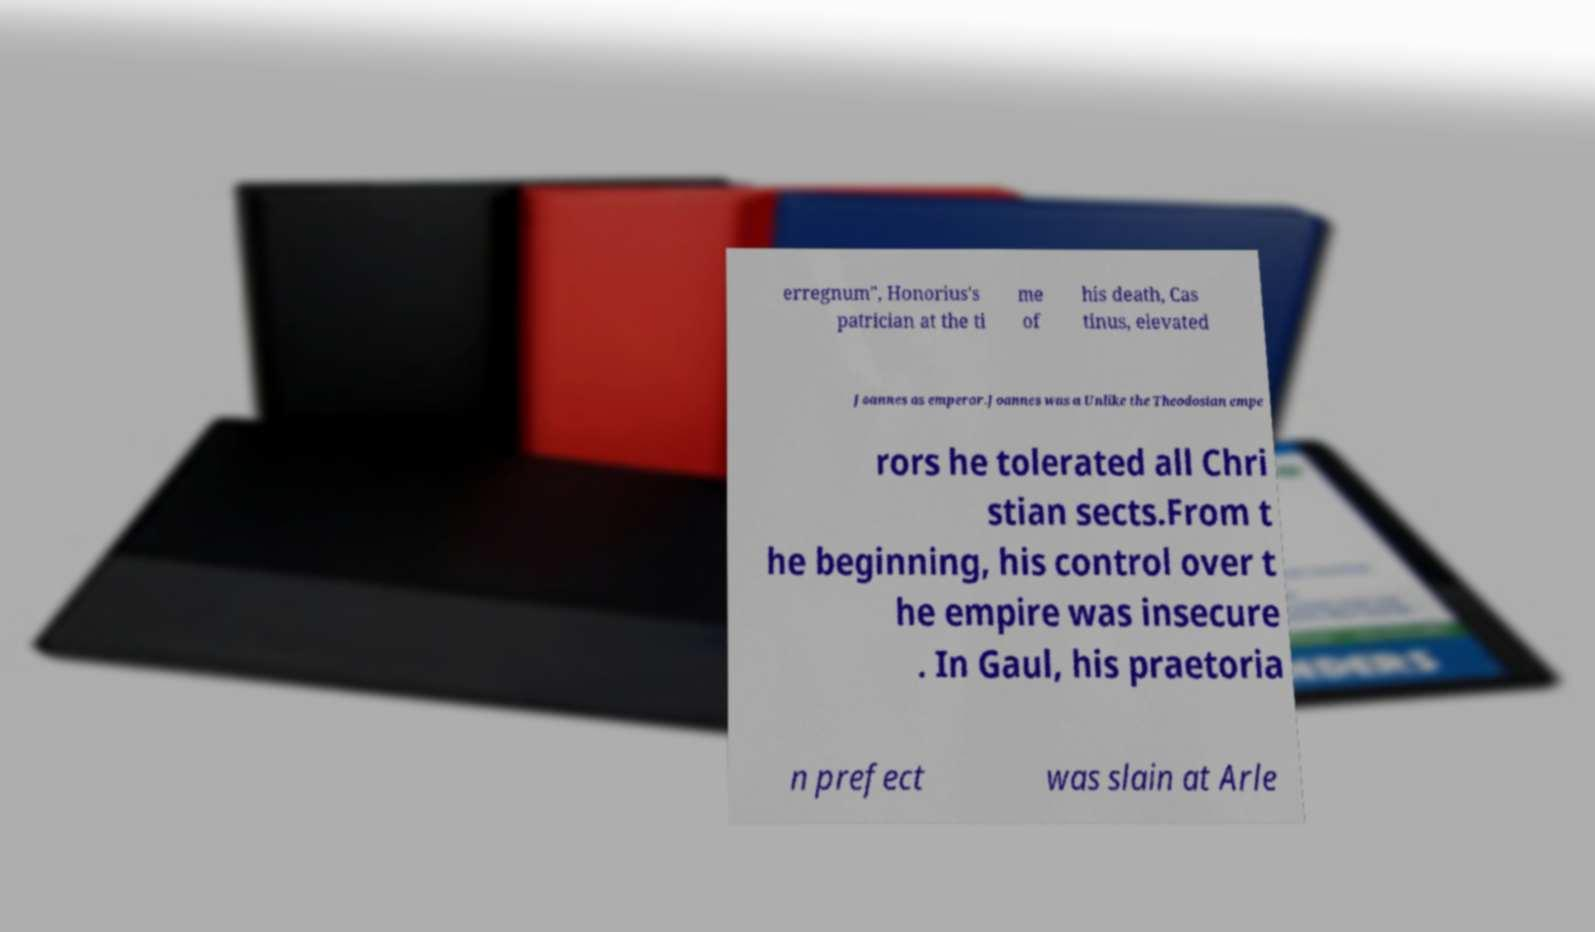For documentation purposes, I need the text within this image transcribed. Could you provide that? erregnum", Honorius's patrician at the ti me of his death, Cas tinus, elevated Joannes as emperor.Joannes was a Unlike the Theodosian empe rors he tolerated all Chri stian sects.From t he beginning, his control over t he empire was insecure . In Gaul, his praetoria n prefect was slain at Arle 